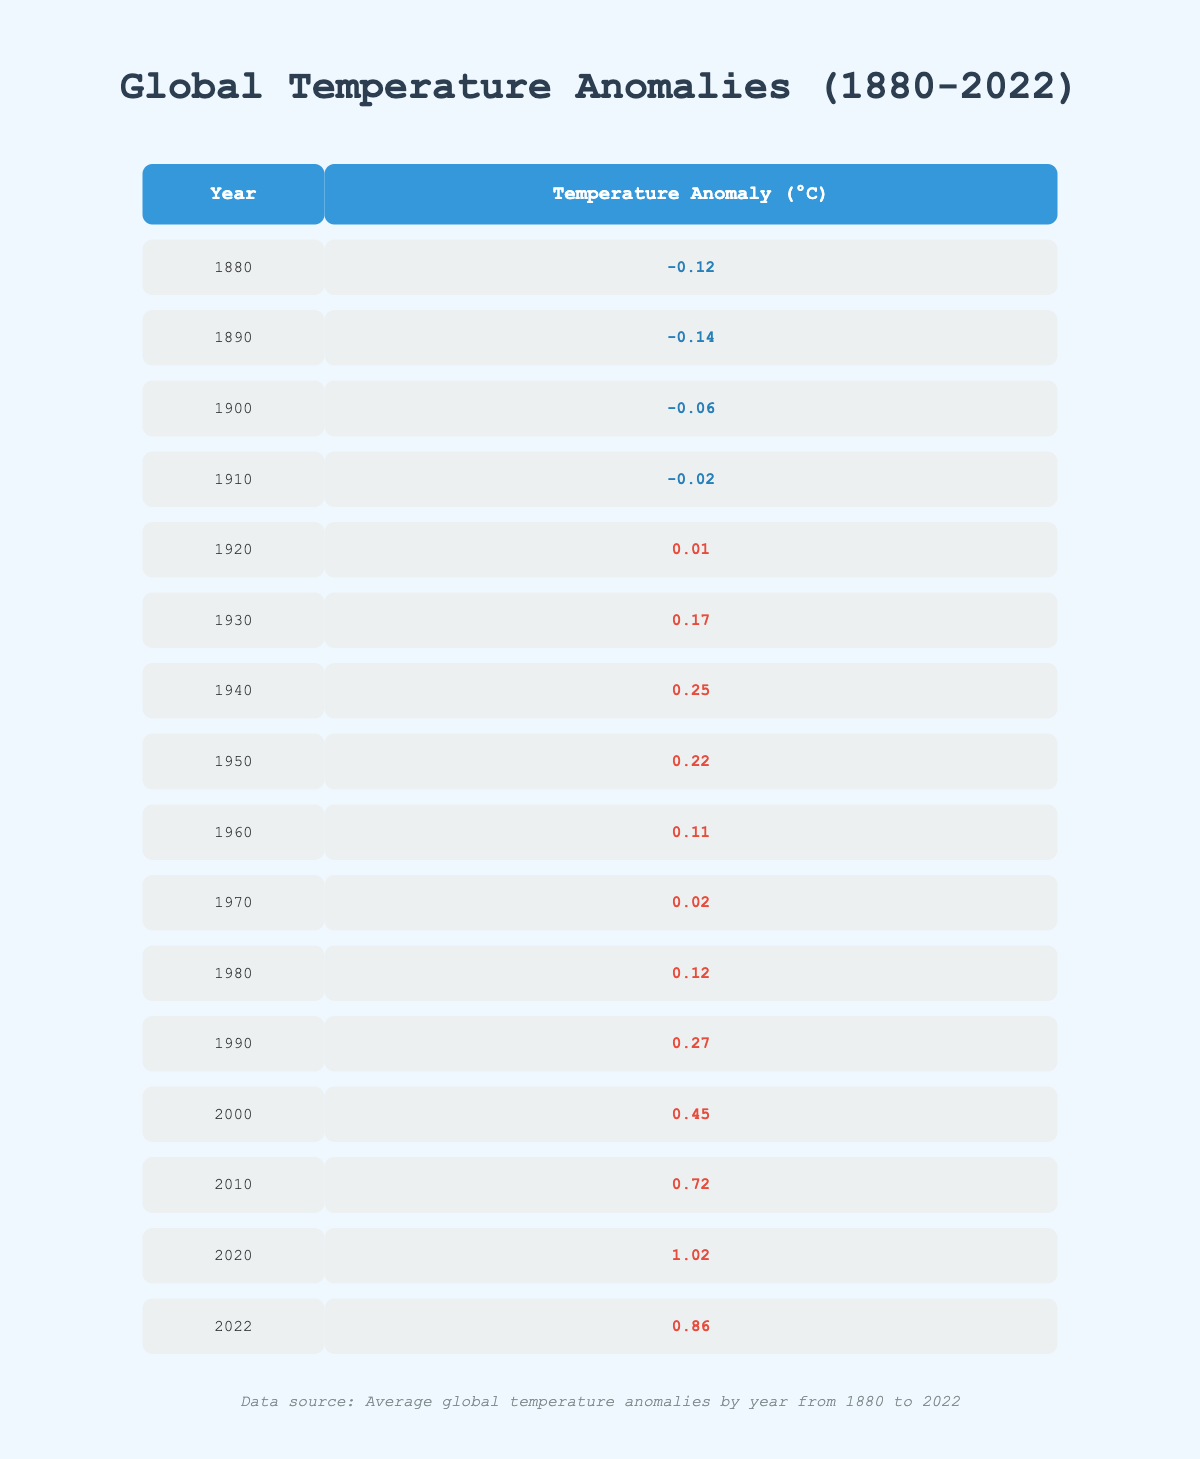What was the average global temperature anomaly in 2000? From the table, the temperature anomaly for the year 2000 is listed as 0.45°C.
Answer: 0.45°C In which year did the temperature anomaly first exceed 0°C? The table shows that the temperature anomaly first exceeded 0°C in 1920, where it is 0.01°C.
Answer: 1920 What was the temperature anomaly in 1910 compared to 2020? The temperature anomaly in 1910 was -0.02°C and in 2020 it was 1.02°C. The difference is 1.02 - (-0.02) = 1.04°C.
Answer: 1.04°C Did the temperature anomaly increase every decade from 1910 to 2020? By examining the data, the anomalies fluctuated and did not consistently increase every decade, particularly noted between 1940 and 1950 where it decreased slightly.
Answer: No What was the highest temperature anomaly recorded in the dataset? The highest temperature anomaly recorded is 1.02°C in the year 2020.
Answer: 1.02°C What was the average temperature anomaly from 2010 to 2022? The temperature anomalies for those years are 0.72 (2010), 1.02 (2020), and 0.86 (2022). The average is calculated as (0.72 + 1.02 + 0.86) / 3 = 0.8667°C.
Answer: 0.87°C Was there a significant increase in temperature anomaly from 1990 to 2000? The anomaly in 1990 was 0.27°C and in 2000 was 0.45°C, indicating an increase of 0.45 - 0.27 = 0.18°C. This is a significant positive change.
Answer: Yes Comparing the anomalies of 1950 and 2000, which year had a higher anomaly and by how much? The anomaly in 1950 was 0.22°C and in 2000 it was 0.45°C. The difference is 0.45 - 0.22 = 0.23°C, meaning 2000 had a higher anomaly by this amount.
Answer: 2000 had a higher anomaly by 0.23°C What trend can be observed in the temperature anomalies over the 142 years? The table indicates a general upward trend in global temperature anomalies over the years, particularly with the most recent years showing significantly higher anomalies.
Answer: An upward trend in anomalies Which decade had notably the highest average temperature anomaly? The decade from 2010 to 2020 had the highest temperature anomalies. If averaged, (0.72 + 0.86 + 1.02) / 3 = 0.8667°C, it shows a high pattern.
Answer: 2010-2020 had the highest average 